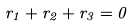Convert formula to latex. <formula><loc_0><loc_0><loc_500><loc_500>r _ { 1 } + r _ { 2 } + r _ { 3 } = 0</formula> 